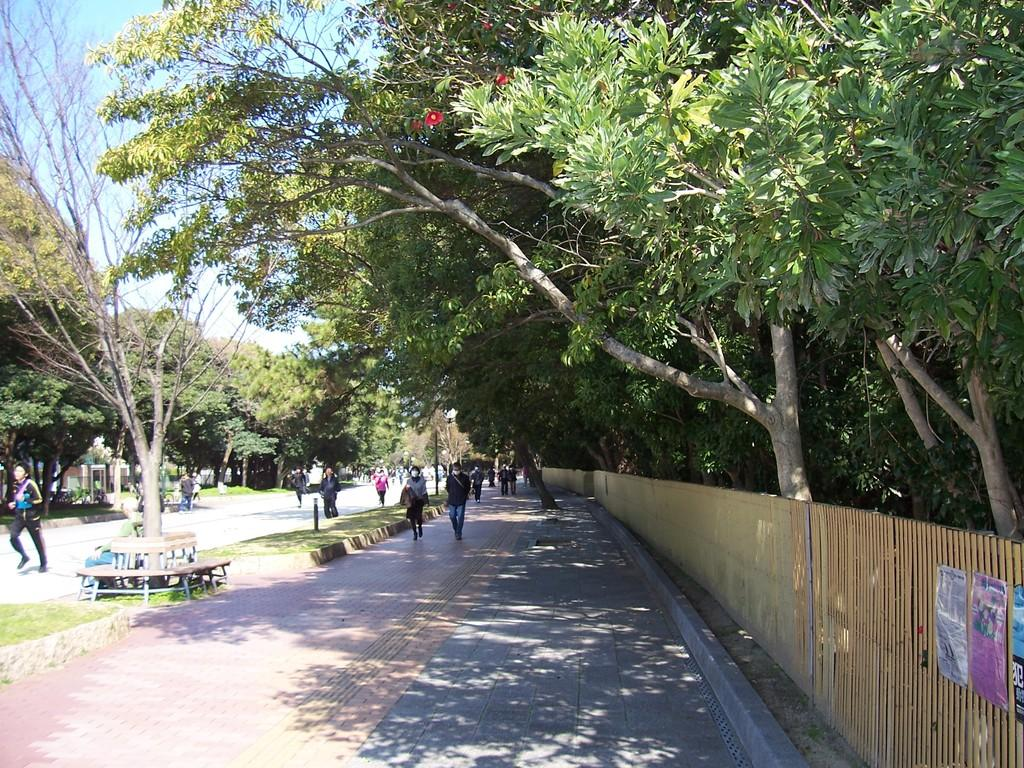What can be seen in the image in terms of human presence? There are people standing on the footpath and road in the image. What type of vegetation is visible in the background of the image? There are trees in the area behind the people. What type of button can be seen floating in the river in the image? There is no river or button present in the image. What thoughts are the people in the image having? We cannot determine the thoughts of the people in the image based on the provided facts. 